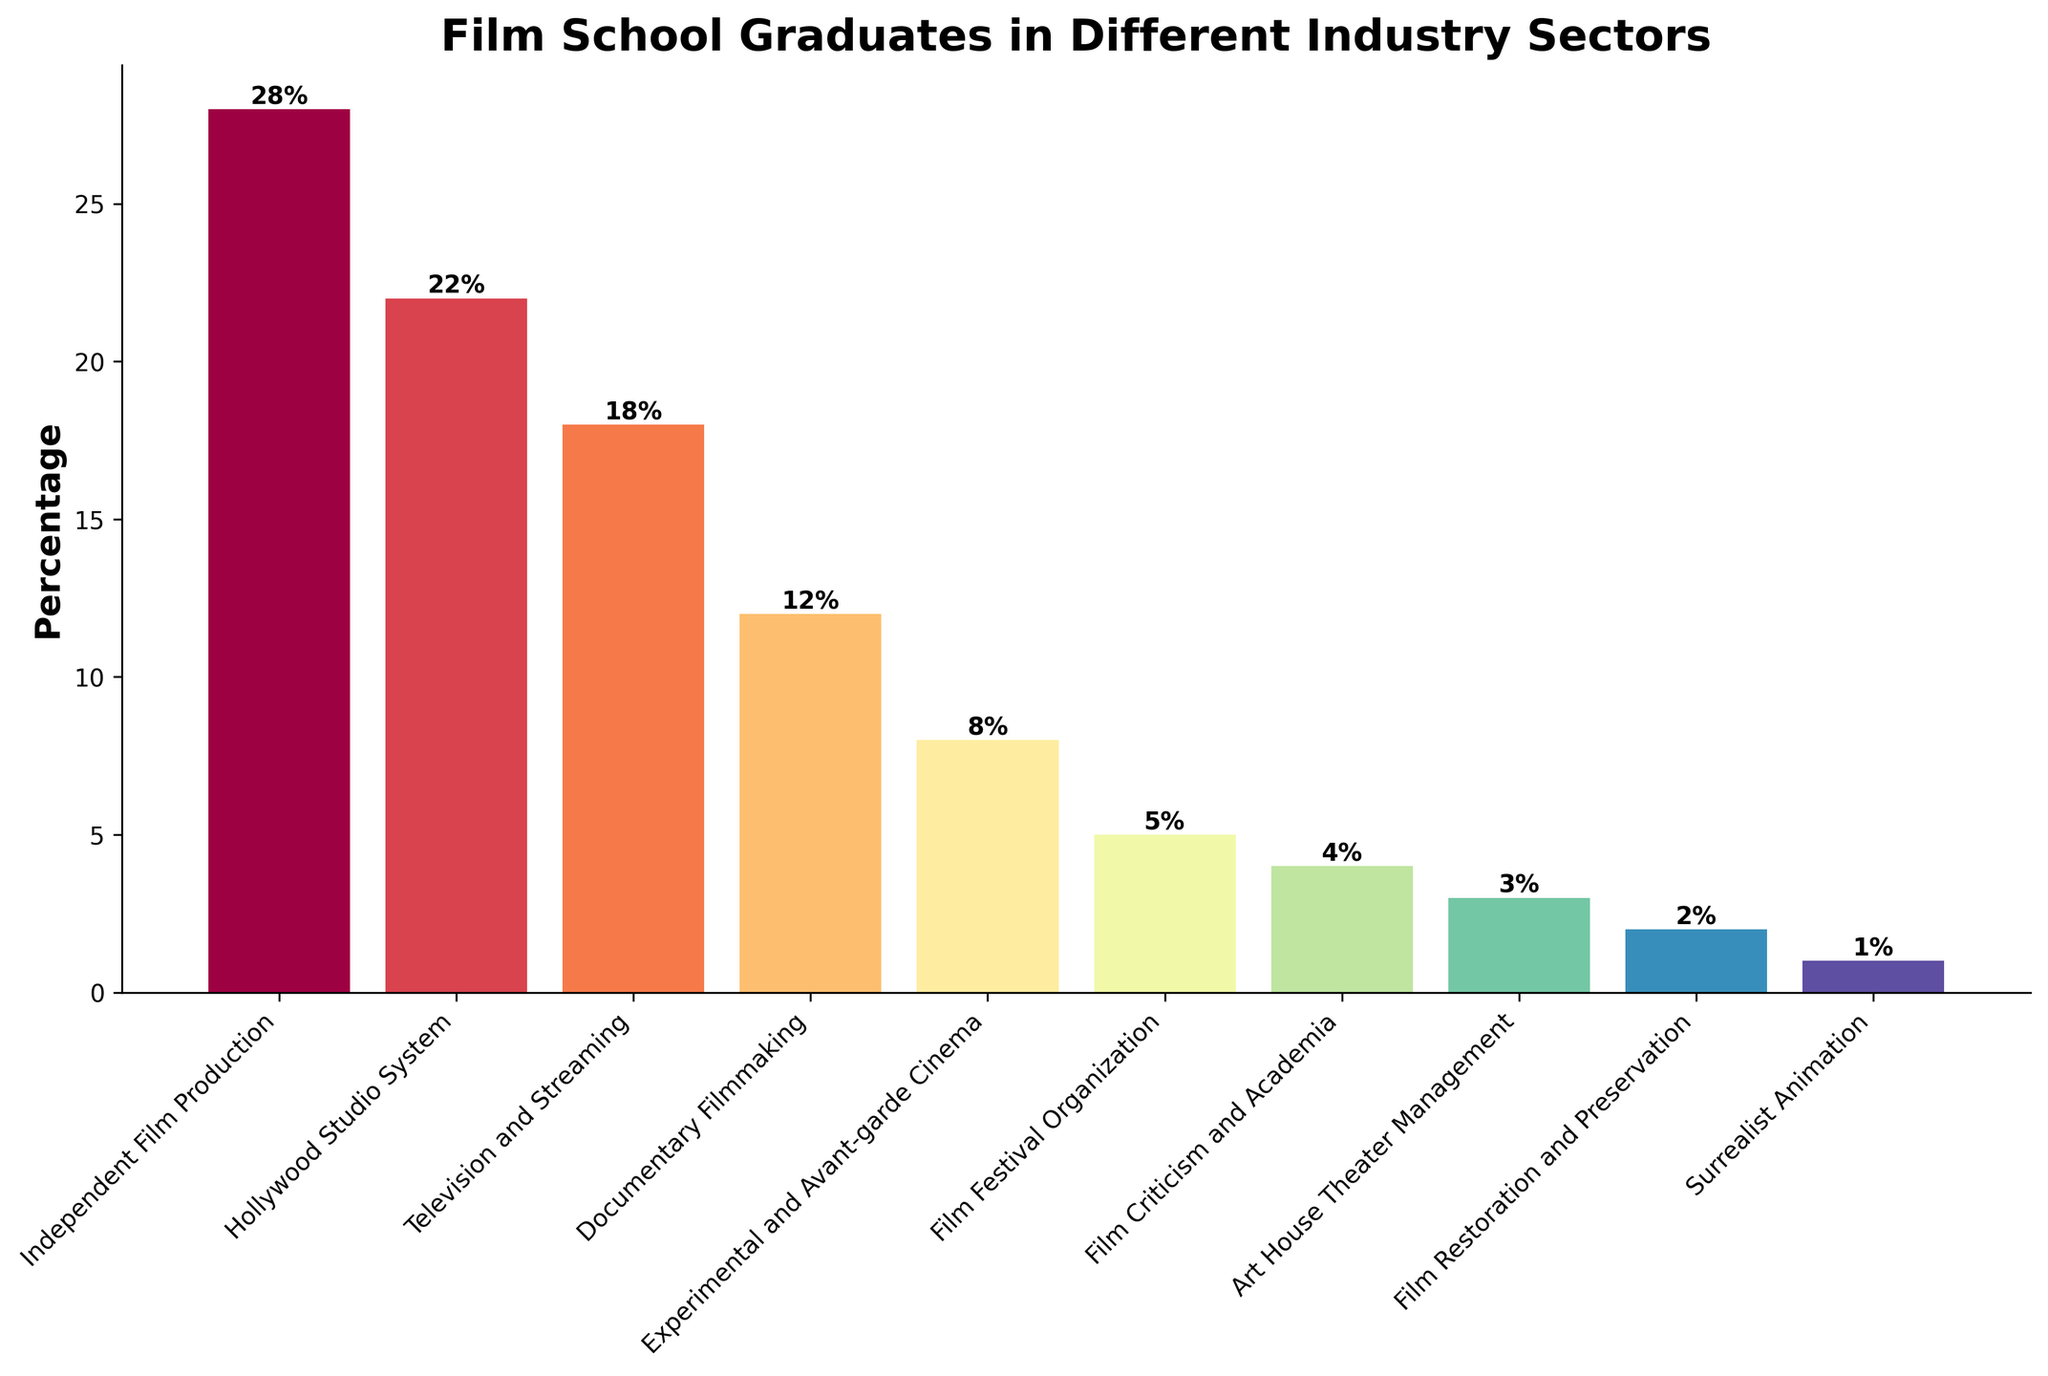Which sector has the highest percentage of film school graduates entering it? The highest bar represents the sector with the highest percentage. The "Independent Film Production" bar is the tallest at 28%.
Answer: Independent Film Production What is the combined percentage of graduates entering the Hollywood Studio System and Television and Streaming sectors? Add the percentages of the Hollywood Studio System (22%) and Television and Streaming (18%): 22% + 18% = 40%.
Answer: 40% Which sector has a higher percentage of graduates, Documentary Filmmaking or Experimental and Avant-garde Cinema? Compare the heights of the bars for "Documentary Filmmaking" (12%) and "Experimental and Avant-garde Cinema" (8%). Documentary Filmmaking is higher.
Answer: Documentary Filmmaking How many sectors have a percentage lower than 5%? Count the bars with percentages less than 5%: "Film Criticism and Academia" (4%), "Art House Theater Management" (3%), "Film Restoration and Preservation" (2%), and "Surrealist Animation" (1%). There are four.
Answer: 4 What is the percentage difference between the highest and lowest sectors? Subtract the lowest percentage (Surrealist Animation at 1%) from the highest percentage (Independent Film Production at 28%): 28% - 1% = 27%.
Answer: 27% Is the percentage of graduates entering Film Festival Organization more or less than the percentage entering Experimental and Avant-garde Cinema? Compare the heights of the bars for "Film Festival Organization" (5%) and "Experimental and Avant-garde Cinema" (8%). Film Festival Organization is less.
Answer: Less What is the average percentage of graduates entering the top three sectors? Sum the percentages of the top three sectors (Independent Film Production at 28%, Hollywood Studio System at 22%, and Television and Streaming at 18%) and divide by 3: (28% + 22% + 18%) / 3 = 22.67%.
Answer: 22.67% By how much does the percentage of graduates entering Independent Film Production exceed that of those entering Television and Streaming? Subtract the percentage of graduates entering Television and Streaming (18%) from Independent Film Production (28%): 28% - 18% = 10%.
Answer: 10% Which sector, between Film Criticism and Academia and Art House Theater Management, has the larger percentage of graduates? Compare the heights of the bars for "Film Criticism and Academia" (4%) and "Art House Theater Management" (3%). Film Criticism and Academia is larger.
Answer: Film Criticism and Academia What is the combined percentage of graduates entering the bottom three sectors? Add the percentages of the bottom three sectors: "Film Restoration and Preservation" (2%), "Surrealist Animation" (1%), and "Art House Theater Management" (3%): 2% + 1% + 3% = 6%.
Answer: 6% 